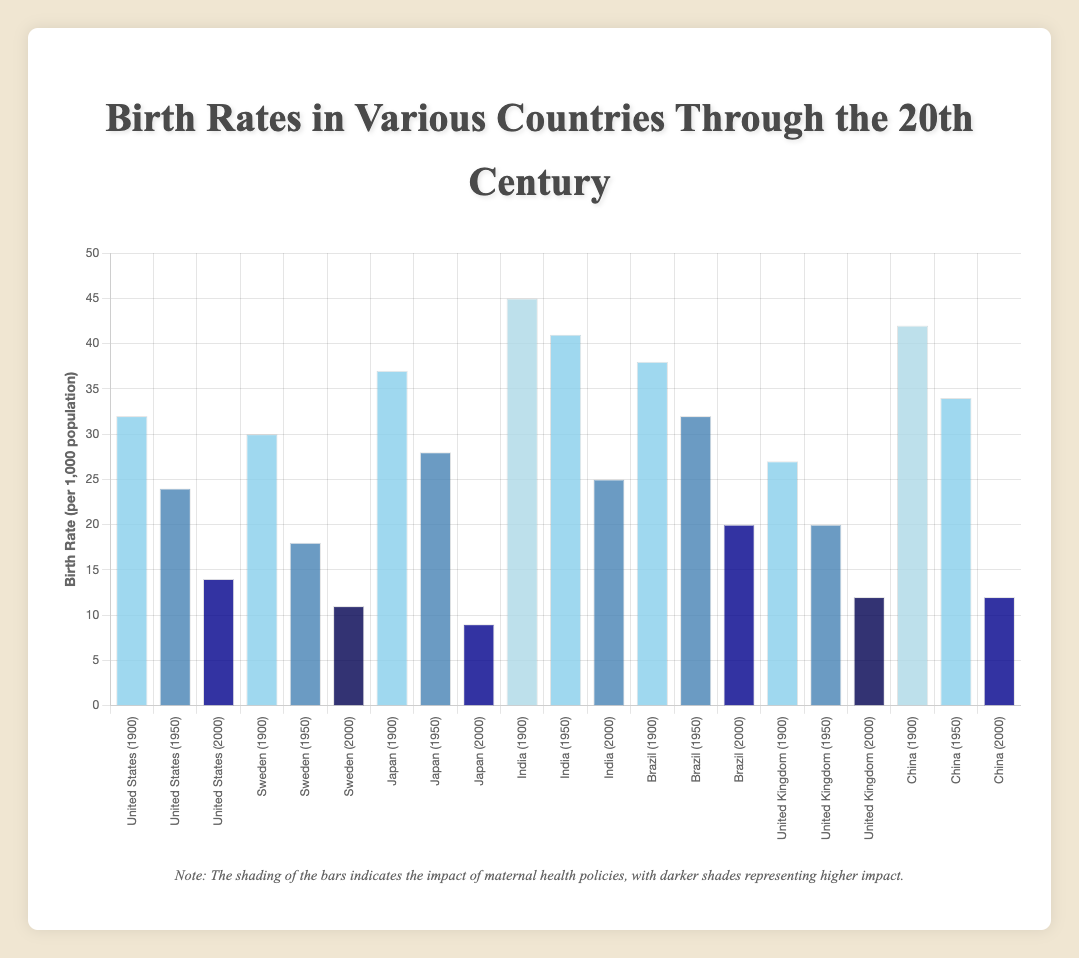Which country had the highest birth rate in the year 2000? To determine this, look at the bars labeled (Year 2000). The highest bar among them represents the highest birth rate.
Answer: India How much did the birth rate in Japan decrease from 1900 to 2000? Identify the birth rates for Japan in 1900 and 2000 from the figure (37 and 9 respectively) and calculate the difference (37 - 9).
Answer: 28 Which country had the largest reduction in birth rate between 1950 and 2000? Calculate the change in birth rates for each country between 1950 and 2000, and then identify the country with the largest reduction. For example, for Brazil, the change is (32 - 20) = 12. Compare the reductions for all countries.
Answer: Japan What is the average birth rate across all countries in 1900? Add the birth rates of all countries in 1900 and divide by the number of countries. That is (32+30+37+45+38+27+42)/7.
Answer: 35.86 Among the countries with "High" impact of maternal health policies in 2000, which had the lowest birth rate? Identify countries with "High" impact in 2000 (United States, Brazil, Japan, and China) and compare their birth rates (14, 20, 9, and 12 respectively) to find the lowest one.
Answer: Japan What are the colors of the bars for Sweden in 1900 and 2000, and what do they represent? The bars for Sweden in 1900 and 2000 are pale blue (low impact) and dark blue (very high impact), respectively.
Answer: Pale blue (Low), Dark blue (Very high) Which country shows a "Very Low" impact of maternal health policies in 1900 and how does their birth rate in 1900 compare to their rate in 2000? Identify the country with "Very Low" impact in 1900 (India and China), then check their birth rates in both years. For India: 45 (1900) vs 25 (2000). For China: 42 (1900) vs 12 (2000).
Answer: India (45 vs 25) What is the combined birth rate of the United Kingdom and Sweden in 1950? Add the birth rates of the United Kingdom and Sweden in 1950, which are 20 and 18, respectively. The combined birth rate is (20 + 18).
Answer: 38 Compare the birth rates of the United States and Brazil in 1950. Which one is higher and by how much? Examine the birth rates for both countries in 1950. The United States has a birth rate of 24, while Brazil has 32. The difference is (32 - 24).
Answer: Brazil by 8 Is there a correlation between the impact of maternal health policies and birth rates over time in the United States? Observe the trend in birth rates and the impact of maternal health policies for the United States from 1900 to 2000: Birth rates decline as the impact of maternal health policies increases from low to high.
Answer: Yes 